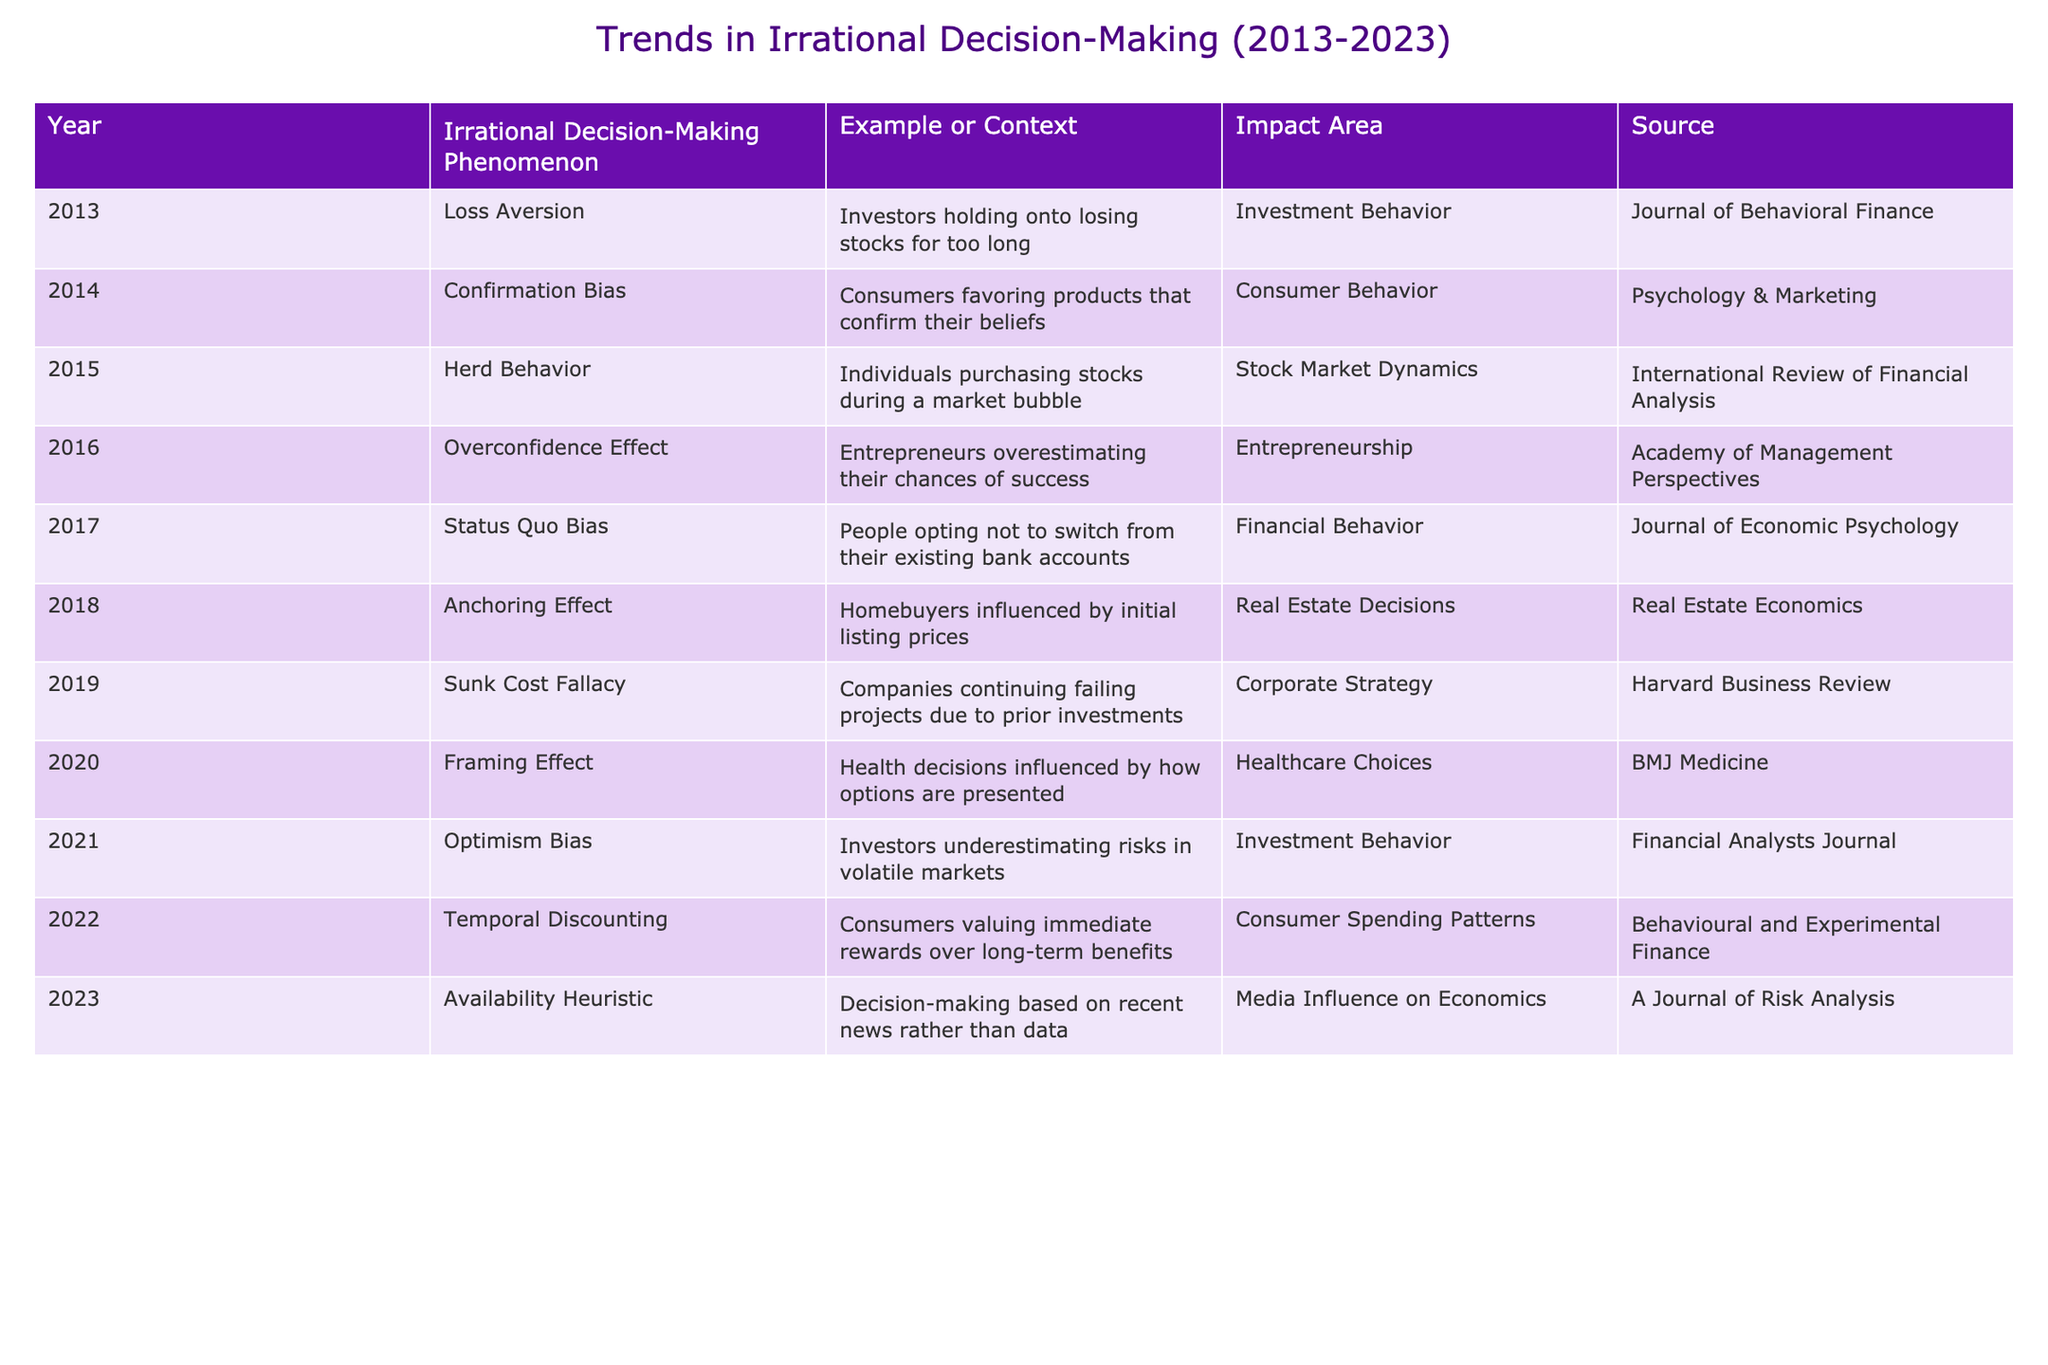What was the earliest identified phenomenon of irrational decision-making in the table? In the table, the earliest year listed is 2013, and the associated phenomenon for that year is "Loss Aversion." Therefore, the earliest phenomenon is loss aversion.
Answer: Loss Aversion How many different irrational decision-making phenomena are documented in the table? The table contains entries from 2013 to 2023, totaling 11 years. Each year represents a distinct phenomenon of irrational decision-making, so there are 11 phenomena documented in total.
Answer: 11 Which year saw the entry of the "Sunk Cost Fallacy"? By inspecting the table, "Sunk Cost Fallacy" is recorded in the year 2019. Therefore, 2019 is the year this phenomenon was added.
Answer: 2019 Is the "Availability Heuristic" associated with the healthcare sector? The "Availability Heuristic" is listed under the "Impact Area" as "Media Influence on Economics" and not the healthcare sector, confirming that this statement is false.
Answer: No What impact areas are associated with the most phenomena, according to the table? Analyzing the impact areas listed, "Investment Behavior" appears twice for both years 2013 and 2021. If we list them, the areas with the highest occurrences are the ones that repeat in the data.
Answer: Investment Behavior What is the most recent irrational decision-making phenomenon documented and its impact area? The most recent year listed in the table is 2023, and the corresponding phenomenon is "Availability Heuristic," which has the impact area of "Media Influence on Economics."
Answer: Availability Heuristic, Media Influence on Economics Which irrational decision-making phenomenon occurred in 2020 and what was its impact area? Referring to the table, the phenomenon listed for 2020 is the "Framing Effect," with its impact area cited as "Healthcare Choices." Therefore, this phenomenon and its impact area are clear.
Answer: Framing Effect, Healthcare Choices How many of the phenomena are related to consumer behavior? By reviewing the table, the following phenomena are related to consumer behavior: "Confirmation Bias" (2014), "Temporal Discounting" (2022), and "Framing Effect" (2020). Thus, there are three instances linked to consumer behavior.
Answer: 3 Which phenomenon has the implication of overestimating chances of success and what year did it occur? In the table, the "Overconfidence Effect" phenomenon is mentioned for the year 2016. This phenomenon specifically implies overestimating chances of success.
Answer: Overconfidence Effect, 2016 What trend can be inferred about the types of irrational decision-making over the past decade? Analyzing the table, it is evident that irrational decision-making has a range of phenomena linked to areas such as investment, consumer behavior, and healthcare. This shows that various sectors are affected by irrationality consistently over years.
Answer: Varied Impact Across Sectors 